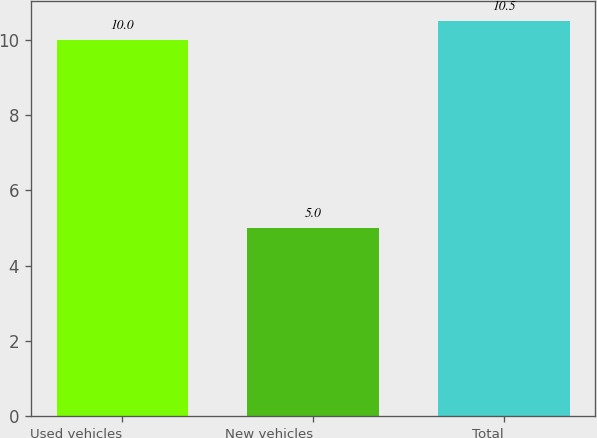Convert chart. <chart><loc_0><loc_0><loc_500><loc_500><bar_chart><fcel>Used vehicles<fcel>New vehicles<fcel>Total<nl><fcel>10<fcel>5<fcel>10.5<nl></chart> 